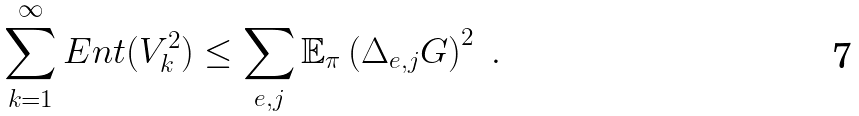Convert formula to latex. <formula><loc_0><loc_0><loc_500><loc_500>\sum _ { k = 1 } ^ { \infty } E n t ( V _ { k } ^ { 2 } ) \leq \sum _ { e , j } \mathbb { E } _ { \pi } \left ( \Delta _ { e , j } G \right ) ^ { 2 } \ .</formula> 